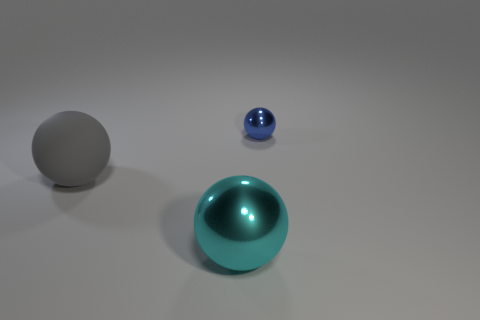What number of big shiny things are the same color as the matte sphere? There are no big shiny objects that are the same color as the matte sphere. The matte sphere is grey, while the larger shiny sphere is teal, and the smaller one is blue. 